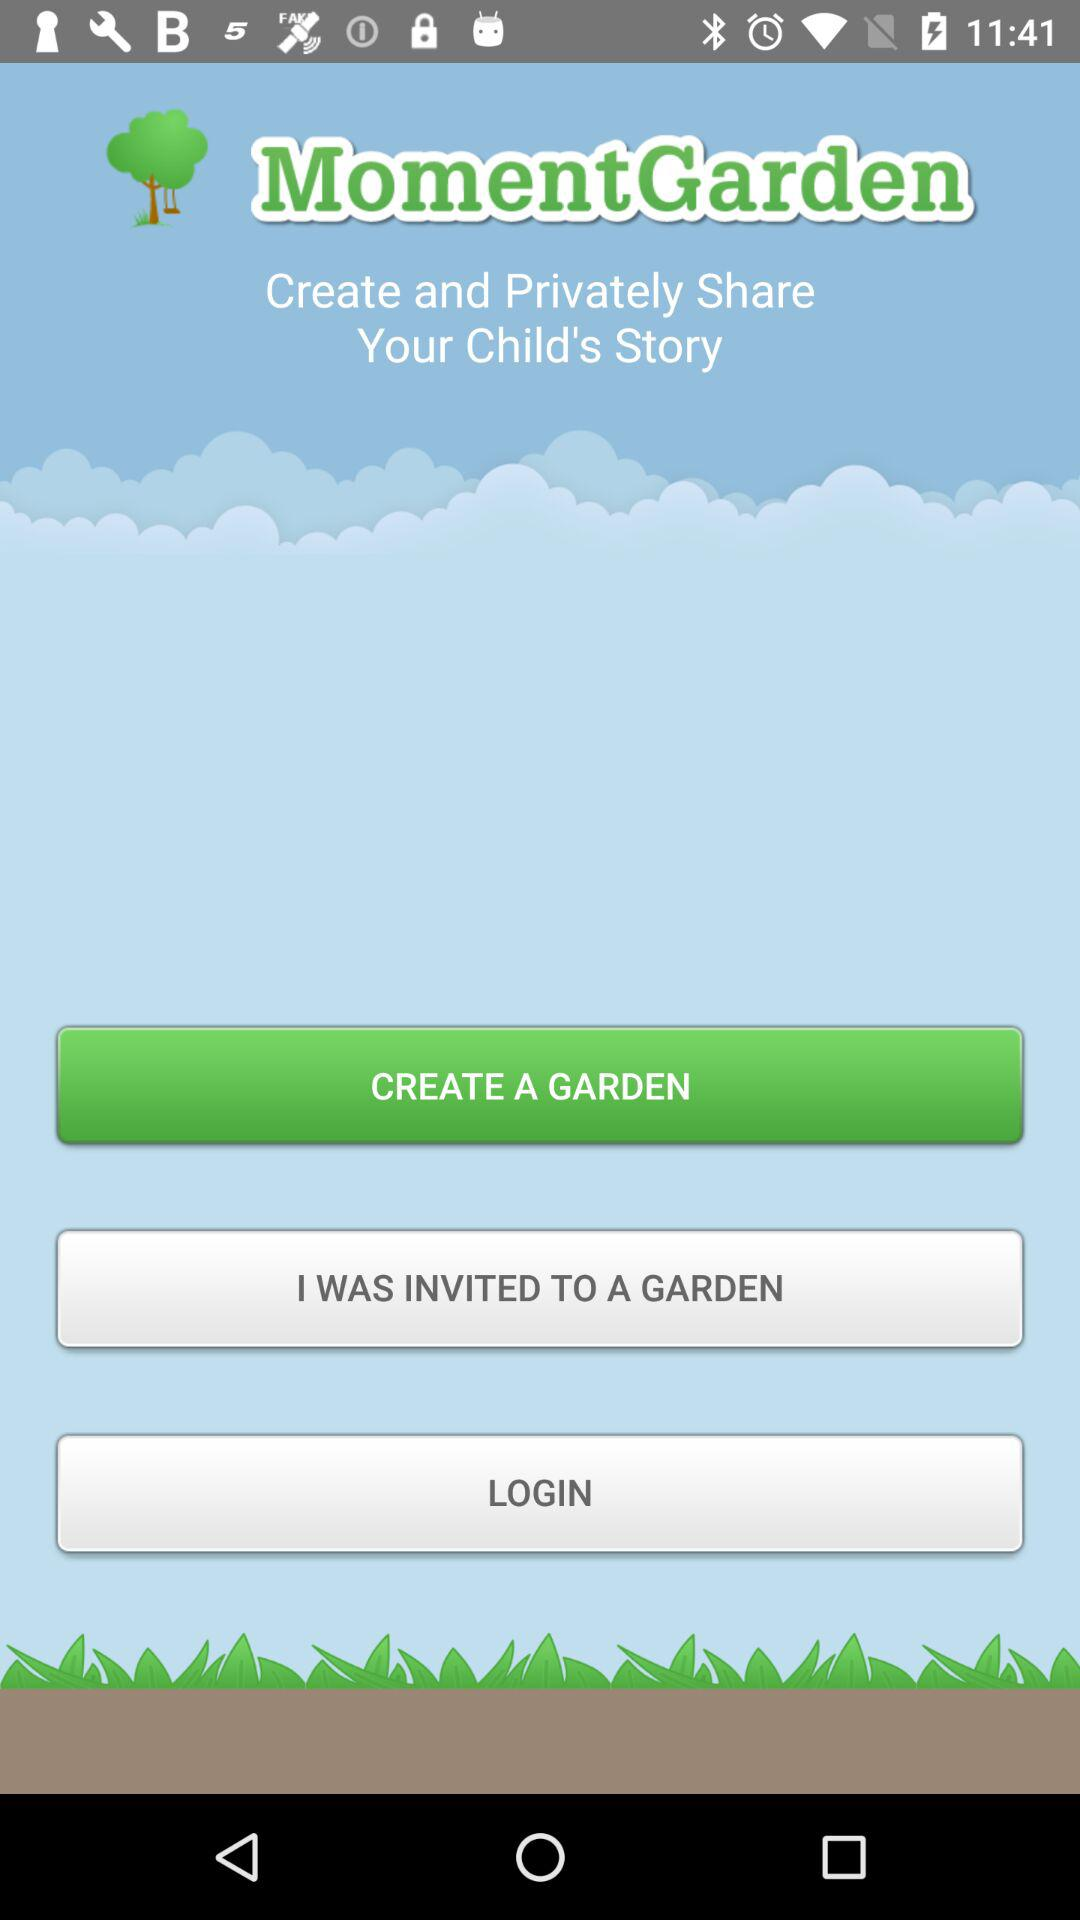What is the application name? The application name is "MomentGarden". 